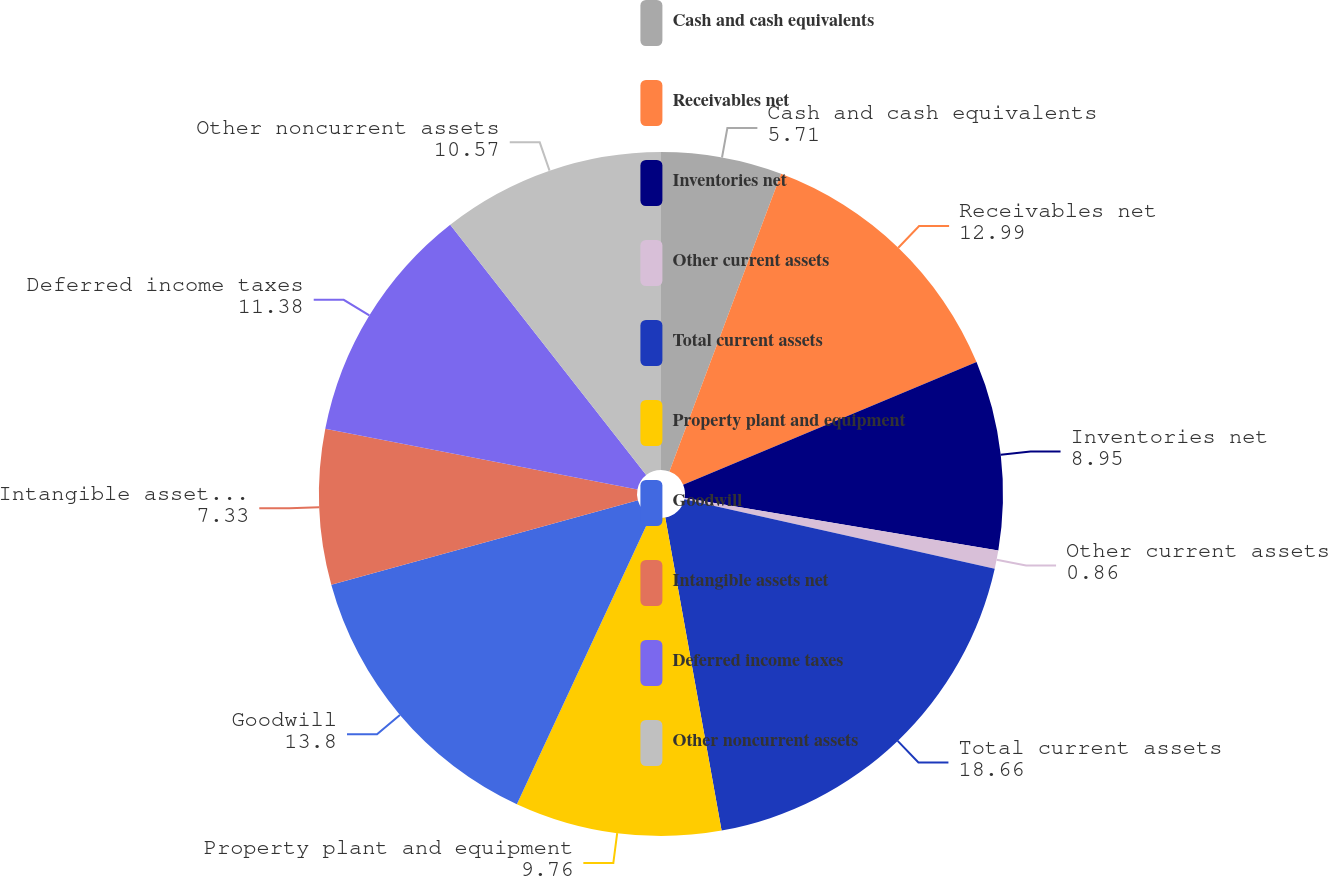Convert chart. <chart><loc_0><loc_0><loc_500><loc_500><pie_chart><fcel>Cash and cash equivalents<fcel>Receivables net<fcel>Inventories net<fcel>Other current assets<fcel>Total current assets<fcel>Property plant and equipment<fcel>Goodwill<fcel>Intangible assets net<fcel>Deferred income taxes<fcel>Other noncurrent assets<nl><fcel>5.71%<fcel>12.99%<fcel>8.95%<fcel>0.86%<fcel>18.66%<fcel>9.76%<fcel>13.8%<fcel>7.33%<fcel>11.38%<fcel>10.57%<nl></chart> 